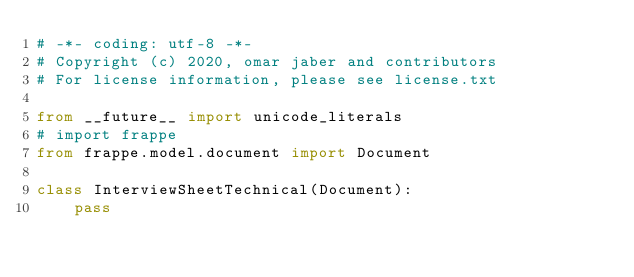<code> <loc_0><loc_0><loc_500><loc_500><_Python_># -*- coding: utf-8 -*-
# Copyright (c) 2020, omar jaber and contributors
# For license information, please see license.txt

from __future__ import unicode_literals
# import frappe
from frappe.model.document import Document

class InterviewSheetTechnical(Document):
	pass
</code> 